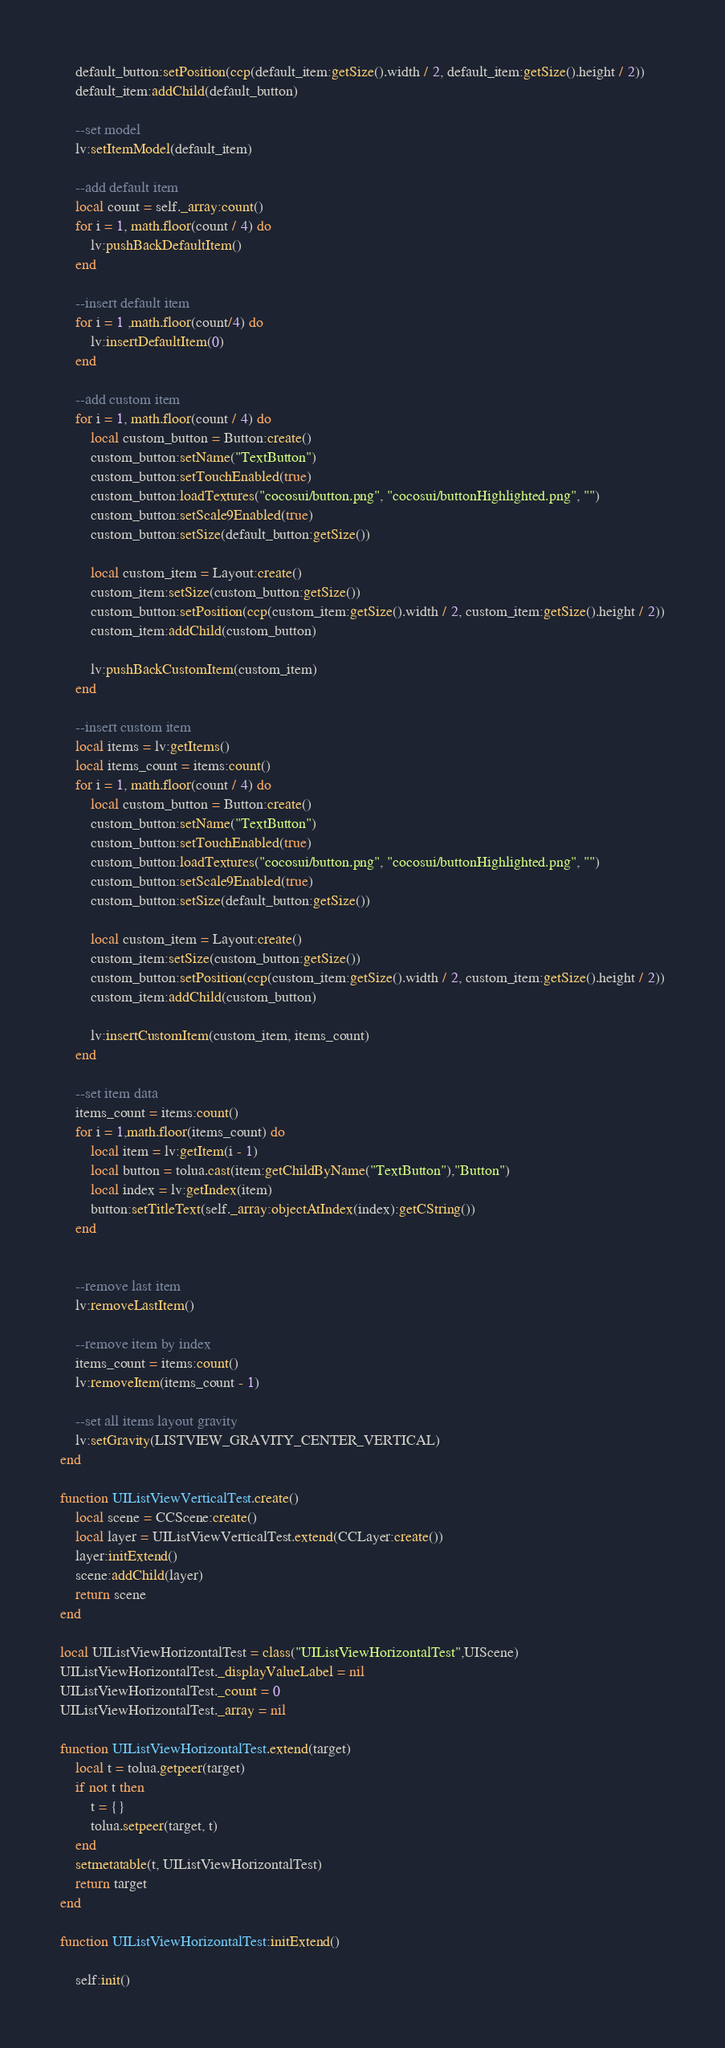Convert code to text. <code><loc_0><loc_0><loc_500><loc_500><_Lua_>    default_button:setPosition(ccp(default_item:getSize().width / 2, default_item:getSize().height / 2))
    default_item:addChild(default_button)
        
    --set model
    lv:setItemModel(default_item)
        
    --add default item
    local count = self._array:count()
    for i = 1, math.floor(count / 4) do
        lv:pushBackDefaultItem()
    end

    --insert default item
    for i = 1 ,math.floor(count/4) do
        lv:insertDefaultItem(0)
    end
        
    --add custom item
    for i = 1, math.floor(count / 4) do
        local custom_button = Button:create()
        custom_button:setName("TextButton")
        custom_button:setTouchEnabled(true)
        custom_button:loadTextures("cocosui/button.png", "cocosui/buttonHighlighted.png", "")
        custom_button:setScale9Enabled(true)
        custom_button:setSize(default_button:getSize())
        
        local custom_item = Layout:create()
        custom_item:setSize(custom_button:getSize())
        custom_button:setPosition(ccp(custom_item:getSize().width / 2, custom_item:getSize().height / 2))
        custom_item:addChild(custom_button)
        
        lv:pushBackCustomItem(custom_item) 
    end

    --insert custom item
    local items = lv:getItems()
    local items_count = items:count()
    for i = 1, math.floor(count / 4) do
        local custom_button = Button:create()
        custom_button:setName("TextButton")
        custom_button:setTouchEnabled(true)
        custom_button:loadTextures("cocosui/button.png", "cocosui/buttonHighlighted.png", "")
        custom_button:setScale9Enabled(true)
        custom_button:setSize(default_button:getSize())
        
        local custom_item = Layout:create()
        custom_item:setSize(custom_button:getSize())
        custom_button:setPosition(ccp(custom_item:getSize().width / 2, custom_item:getSize().height / 2))
        custom_item:addChild(custom_button)
        
        lv:insertCustomItem(custom_item, items_count) 
    end
    
    --set item data
    items_count = items:count()
    for i = 1,math.floor(items_count) do
        local item = lv:getItem(i - 1)
        local button = tolua.cast(item:getChildByName("TextButton"),"Button")
        local index = lv:getIndex(item)
        button:setTitleText(self._array:objectAtIndex(index):getCString())
    end

    
    --remove last item
    lv:removeLastItem()
    
    --remove item by index
    items_count = items:count()
    lv:removeItem(items_count - 1)
    
    --set all items layout gravity
    lv:setGravity(LISTVIEW_GRAVITY_CENTER_VERTICAL)
end

function UIListViewVerticalTest.create()
    local scene = CCScene:create()
    local layer = UIListViewVerticalTest.extend(CCLayer:create())
    layer:initExtend()
    scene:addChild(layer)
    return scene   
end

local UIListViewHorizontalTest = class("UIListViewHorizontalTest",UIScene)
UIListViewHorizontalTest._displayValueLabel = nil
UIListViewHorizontalTest._count = 0
UIListViewHorizontalTest._array = nil

function UIListViewHorizontalTest.extend(target)
    local t = tolua.getpeer(target)
    if not t then
        t = {}
        tolua.setpeer(target, t)
    end
    setmetatable(t, UIListViewHorizontalTest)
    return target
end

function UIListViewHorizontalTest:initExtend()
    
    self:init()
</code> 